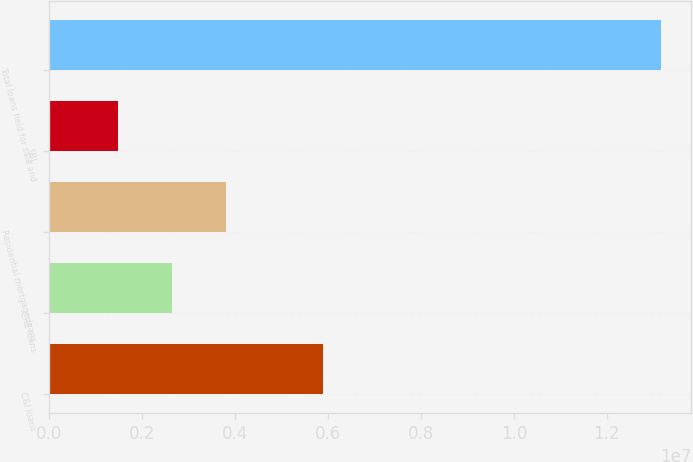Convert chart to OTSL. <chart><loc_0><loc_0><loc_500><loc_500><bar_chart><fcel>C&I loans<fcel>CRE loans<fcel>Residential mortgage loans<fcel>SBL<fcel>Total loans held for sale and<nl><fcel>5.89363e+06<fcel>2.64763e+06<fcel>3.81571e+06<fcel>1.47956e+06<fcel>1.31603e+07<nl></chart> 